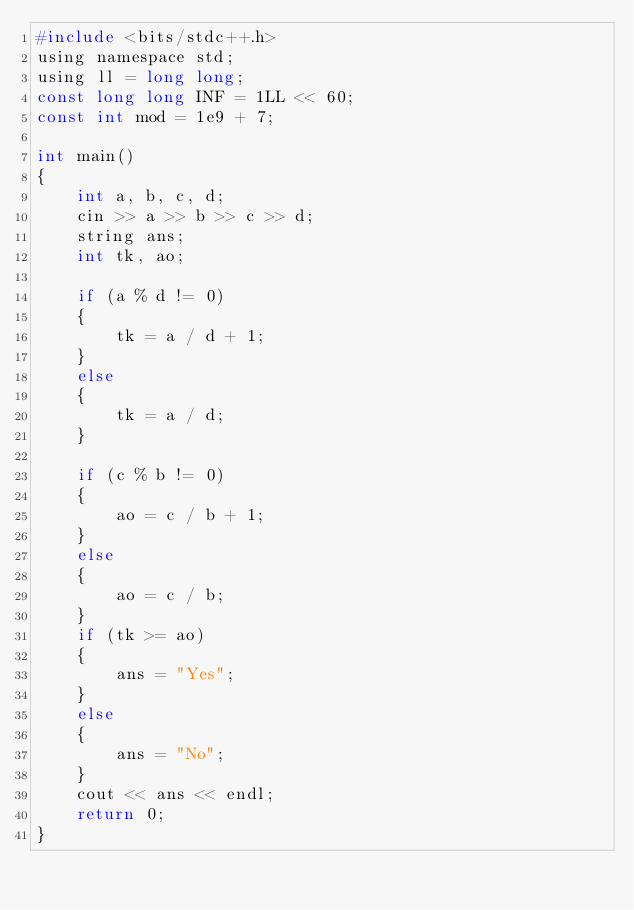Convert code to text. <code><loc_0><loc_0><loc_500><loc_500><_C_>#include <bits/stdc++.h>
using namespace std;
using ll = long long;
const long long INF = 1LL << 60;
const int mod = 1e9 + 7;

int main()
{
    int a, b, c, d;
    cin >> a >> b >> c >> d;
    string ans;
    int tk, ao;

    if (a % d != 0)
    {
        tk = a / d + 1;
    }
    else
    {
        tk = a / d;
    }

    if (c % b != 0)
    {
        ao = c / b + 1;
    }
    else
    {
        ao = c / b;
    }
    if (tk >= ao)
    {
        ans = "Yes";
    }
    else
    {
        ans = "No";
    }
    cout << ans << endl;
    return 0;
}</code> 